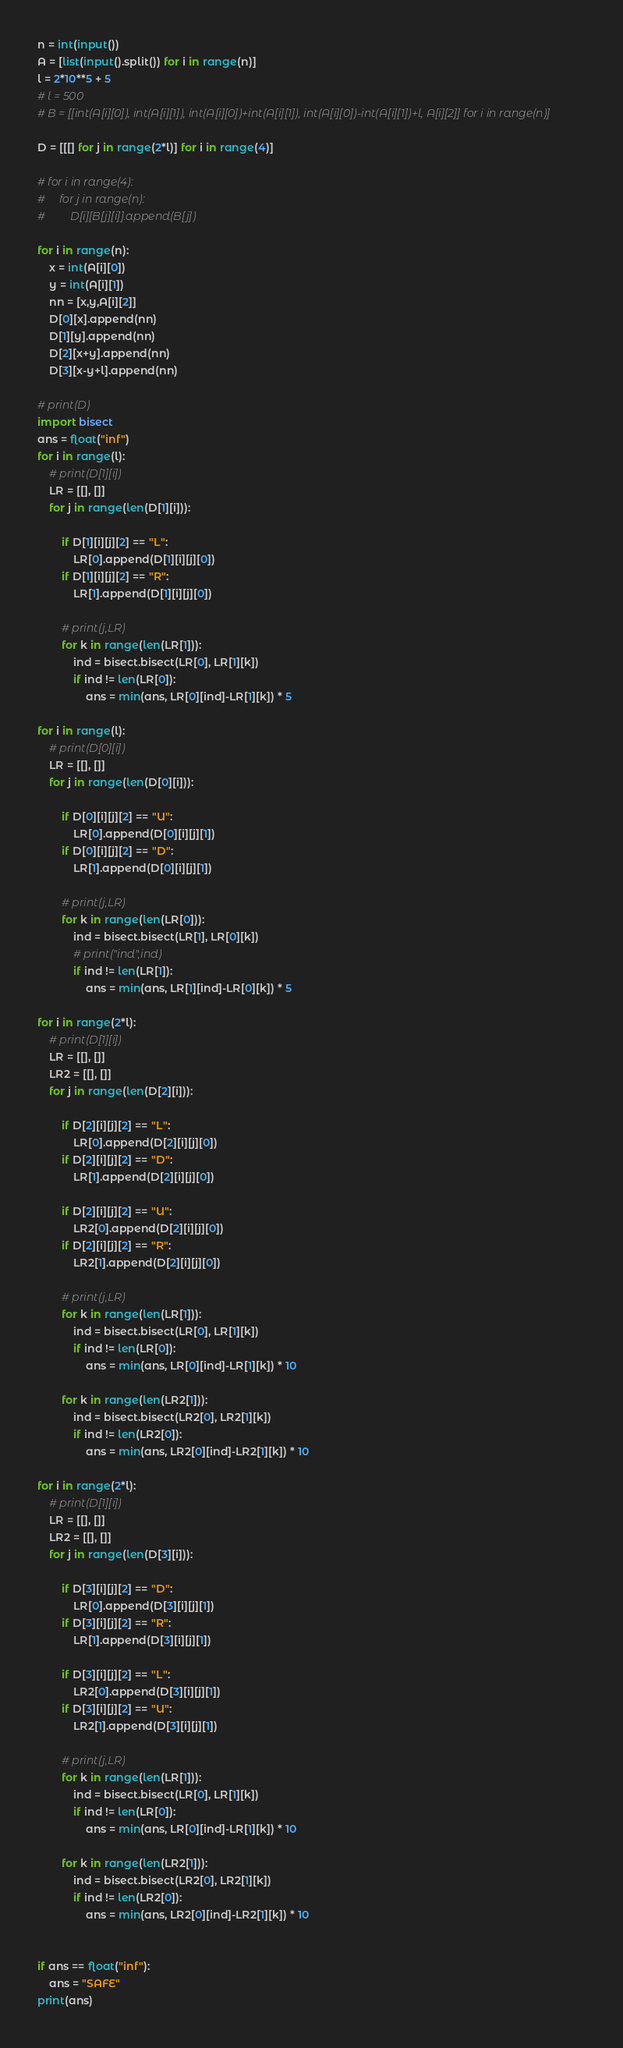<code> <loc_0><loc_0><loc_500><loc_500><_Python_>n = int(input())
A = [list(input().split()) for i in range(n)]
l = 2*10**5 + 5
# l = 500
# B = [[int(A[i][0]), int(A[i][1]), int(A[i][0])+int(A[i][1]), int(A[i][0])-int(A[i][1])+l, A[i][2]] for i in range(n)]

D = [[[] for j in range(2*l)] for i in range(4)]

# for i in range(4):
#     for j in range(n):
#         D[i][B[j][i]].append(B[j])

for i in range(n):
    x = int(A[i][0])
    y = int(A[i][1])
    nn = [x,y,A[i][2]]
    D[0][x].append(nn)
    D[1][y].append(nn)
    D[2][x+y].append(nn)
    D[3][x-y+l].append(nn)

# print(D)
import bisect
ans = float("inf")
for i in range(l):
    # print(D[1][i])
    LR = [[], []]
    for j in range(len(D[1][i])):
        
        if D[1][i][j][2] == "L":
            LR[0].append(D[1][i][j][0])
        if D[1][i][j][2] == "R":
            LR[1].append(D[1][i][j][0])

        # print(j,LR)
        for k in range(len(LR[1])):
            ind = bisect.bisect(LR[0], LR[1][k])
            if ind != len(LR[0]):
                ans = min(ans, LR[0][ind]-LR[1][k]) * 5

for i in range(l):
    # print(D[0][i])
    LR = [[], []]
    for j in range(len(D[0][i])):
        
        if D[0][i][j][2] == "U":
            LR[0].append(D[0][i][j][1])
        if D[0][i][j][2] == "D":
            LR[1].append(D[0][i][j][1])

        # print(j,LR)
        for k in range(len(LR[0])):
            ind = bisect.bisect(LR[1], LR[0][k])
            # print("ind",ind)
            if ind != len(LR[1]):
                ans = min(ans, LR[1][ind]-LR[0][k]) * 5

for i in range(2*l):
    # print(D[1][i])
    LR = [[], []]
    LR2 = [[], []]
    for j in range(len(D[2][i])):
        
        if D[2][i][j][2] == "L":
            LR[0].append(D[2][i][j][0])
        if D[2][i][j][2] == "D":
            LR[1].append(D[2][i][j][0])

        if D[2][i][j][2] == "U":
            LR2[0].append(D[2][i][j][0])
        if D[2][i][j][2] == "R":
            LR2[1].append(D[2][i][j][0])

        # print(j,LR)
        for k in range(len(LR[1])):
            ind = bisect.bisect(LR[0], LR[1][k])
            if ind != len(LR[0]):
                ans = min(ans, LR[0][ind]-LR[1][k]) * 10
        
        for k in range(len(LR2[1])):
            ind = bisect.bisect(LR2[0], LR2[1][k])
            if ind != len(LR2[0]):
                ans = min(ans, LR2[0][ind]-LR2[1][k]) * 10

for i in range(2*l):
    # print(D[1][i])
    LR = [[], []]
    LR2 = [[], []]
    for j in range(len(D[3][i])):
        
        if D[3][i][j][2] == "D":
            LR[0].append(D[3][i][j][1])
        if D[3][i][j][2] == "R":
            LR[1].append(D[3][i][j][1])

        if D[3][i][j][2] == "L":
            LR2[0].append(D[3][i][j][1])
        if D[3][i][j][2] == "U":
            LR2[1].append(D[3][i][j][1])

        # print(j,LR)
        for k in range(len(LR[1])):
            ind = bisect.bisect(LR[0], LR[1][k])
            if ind != len(LR[0]):
                ans = min(ans, LR[0][ind]-LR[1][k]) * 10
        
        for k in range(len(LR2[1])):
            ind = bisect.bisect(LR2[0], LR2[1][k])
            if ind != len(LR2[0]):
                ans = min(ans, LR2[0][ind]-LR2[1][k]) * 10


if ans == float("inf"):
    ans = "SAFE"
print(ans)
</code> 